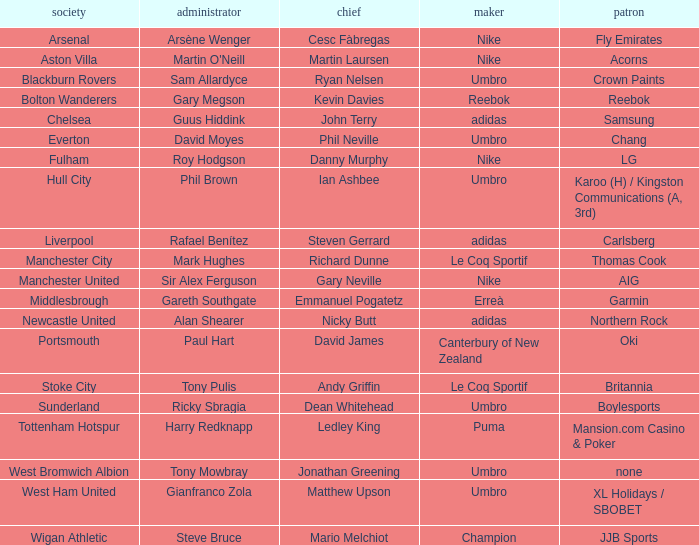Who is the captain of Middlesbrough? Emmanuel Pogatetz. 